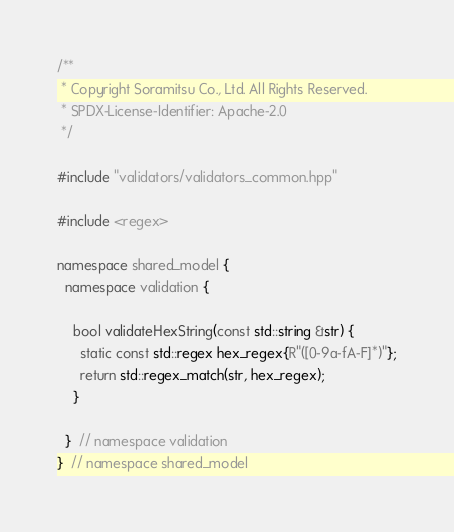Convert code to text. <code><loc_0><loc_0><loc_500><loc_500><_C++_>/**
 * Copyright Soramitsu Co., Ltd. All Rights Reserved.
 * SPDX-License-Identifier: Apache-2.0
 */

#include "validators/validators_common.hpp"

#include <regex>

namespace shared_model {
  namespace validation {

    bool validateHexString(const std::string &str) {
      static const std::regex hex_regex{R"([0-9a-fA-F]*)"};
      return std::regex_match(str, hex_regex);
    }

  }  // namespace validation
}  // namespace shared_model
</code> 